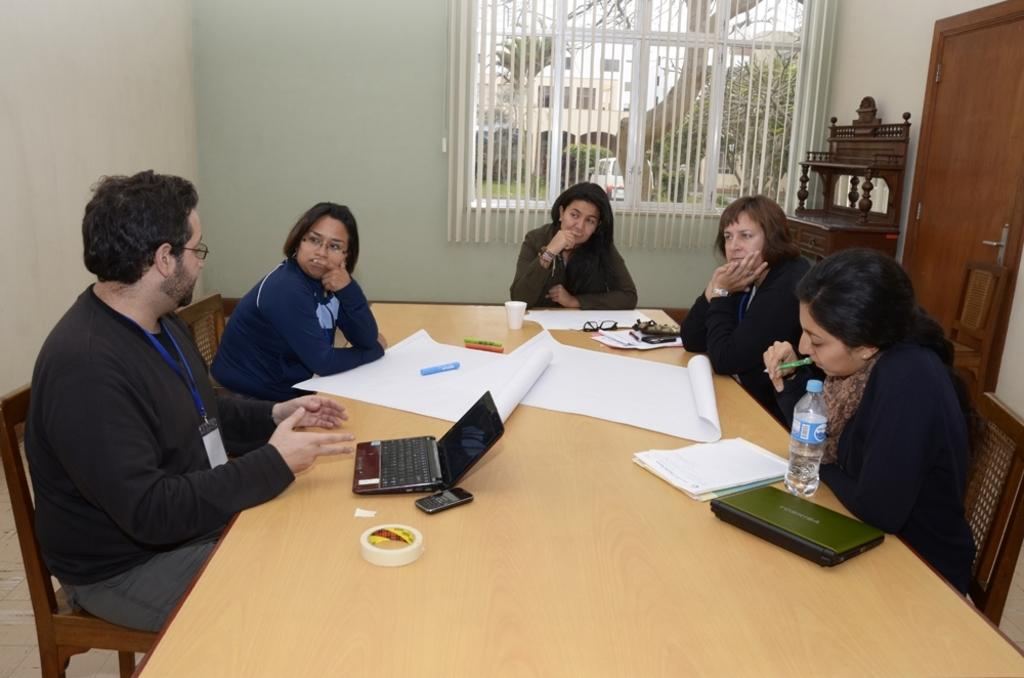How many people are in the image? There is a group of people in the image. What are the people doing in the image? The people are talking to each other. What is on the table in the image? There are white sheets, a laptop, and a water bottle on the table. What object might be used for communication in the image? The laptop on the table might be used for communication. How many legs can be seen on the snake in the image? There is no snake present in the image. What type of plough is being used by the people in the image? There is no plough present in the image; it features a group of people talking to each other around a table. 